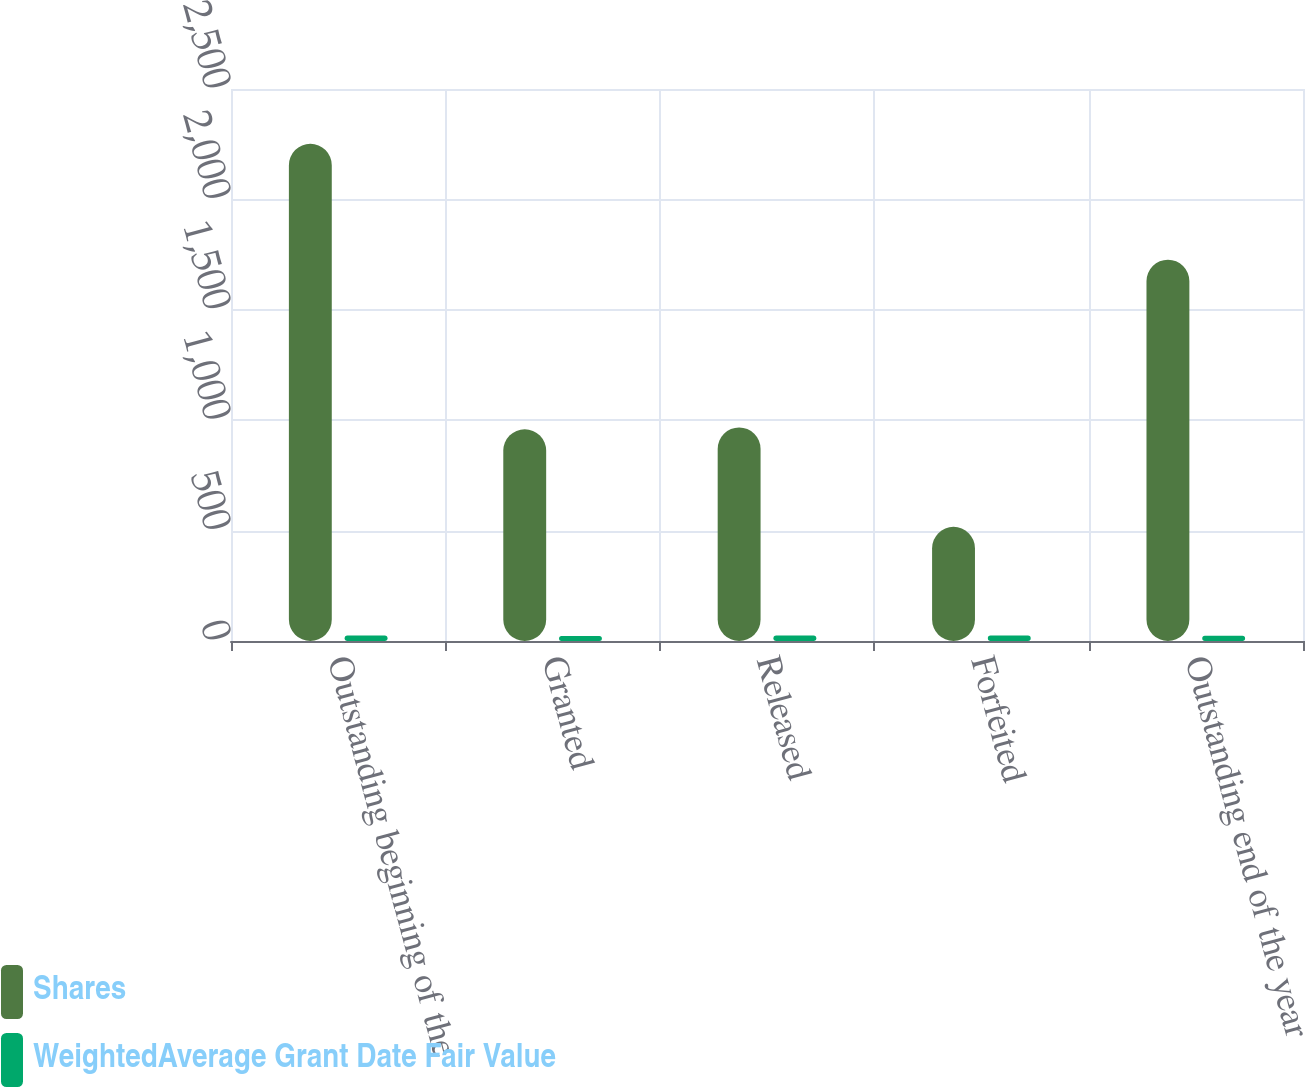Convert chart. <chart><loc_0><loc_0><loc_500><loc_500><stacked_bar_chart><ecel><fcel>Outstanding beginning of the<fcel>Granted<fcel>Released<fcel>Forfeited<fcel>Outstanding end of the year<nl><fcel>Shares<fcel>2252<fcel>959<fcel>967<fcel>517<fcel>1727<nl><fcel>WeightedAverage Grant Date Fair Value<fcel>24.91<fcel>22.92<fcel>25.11<fcel>24.6<fcel>23.79<nl></chart> 